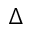<formula> <loc_0><loc_0><loc_500><loc_500>\Delta</formula> 